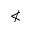<formula> <loc_0><loc_0><loc_500><loc_500>\nless</formula> 